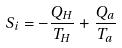<formula> <loc_0><loc_0><loc_500><loc_500>S _ { i } = - \frac { Q _ { H } } { T _ { H } } + \frac { Q _ { a } } { T _ { a } }</formula> 